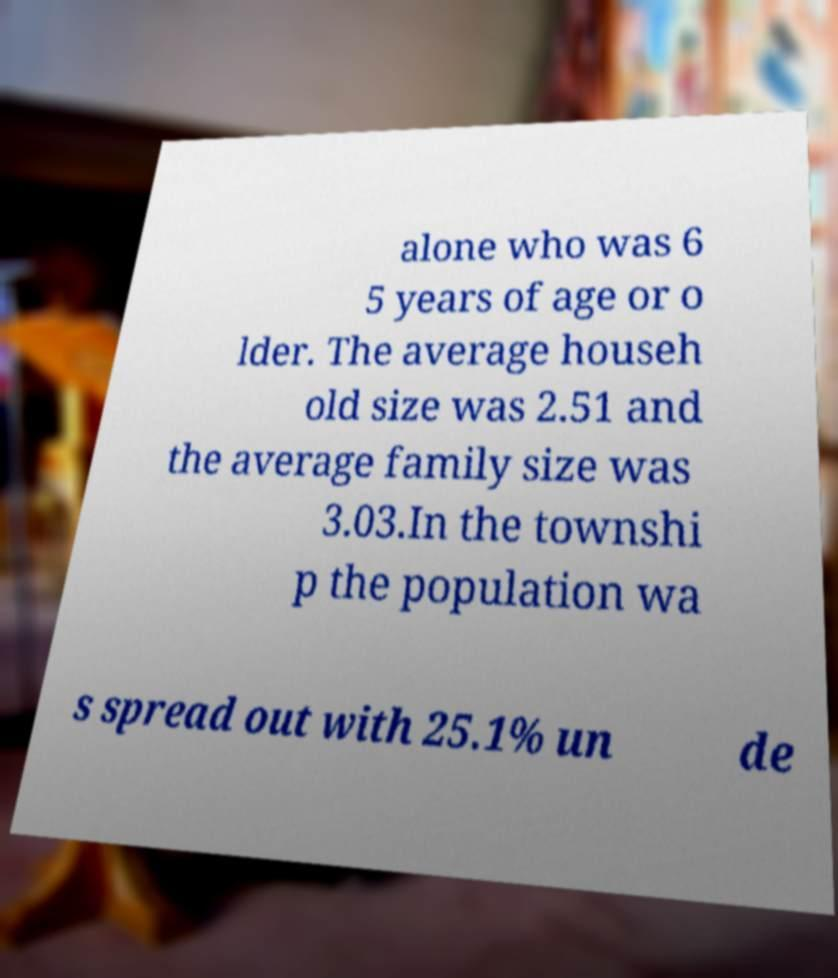Could you extract and type out the text from this image? alone who was 6 5 years of age or o lder. The average househ old size was 2.51 and the average family size was 3.03.In the townshi p the population wa s spread out with 25.1% un de 